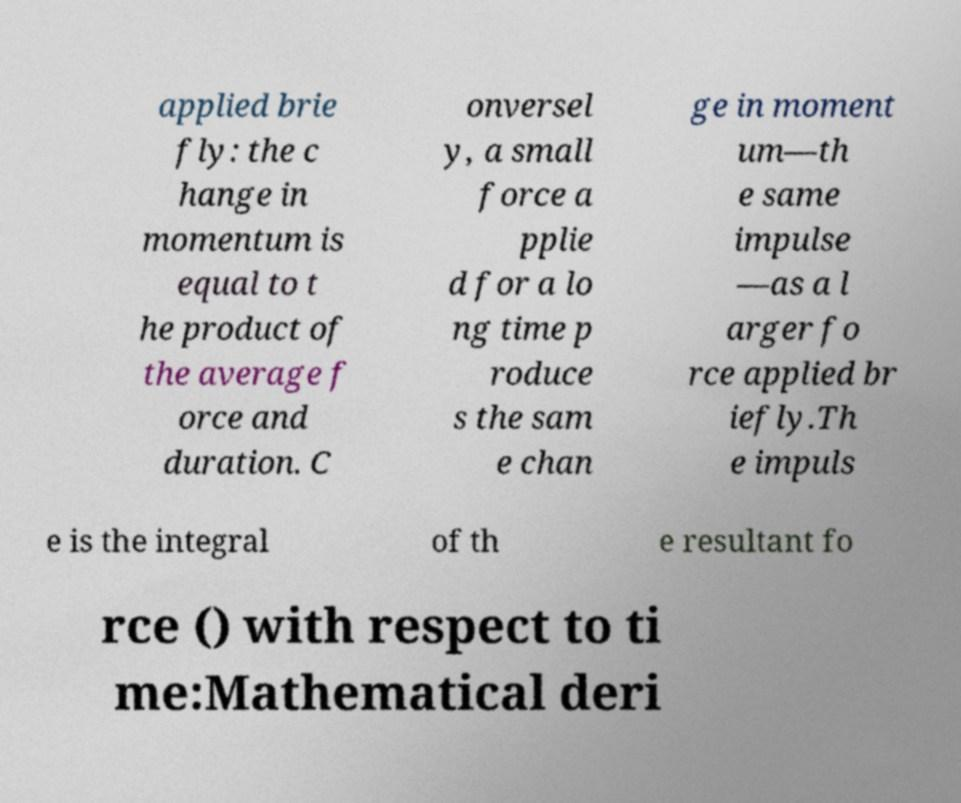Could you assist in decoding the text presented in this image and type it out clearly? applied brie fly: the c hange in momentum is equal to t he product of the average f orce and duration. C onversel y, a small force a pplie d for a lo ng time p roduce s the sam e chan ge in moment um—th e same impulse —as a l arger fo rce applied br iefly.Th e impuls e is the integral of th e resultant fo rce () with respect to ti me:Mathematical deri 